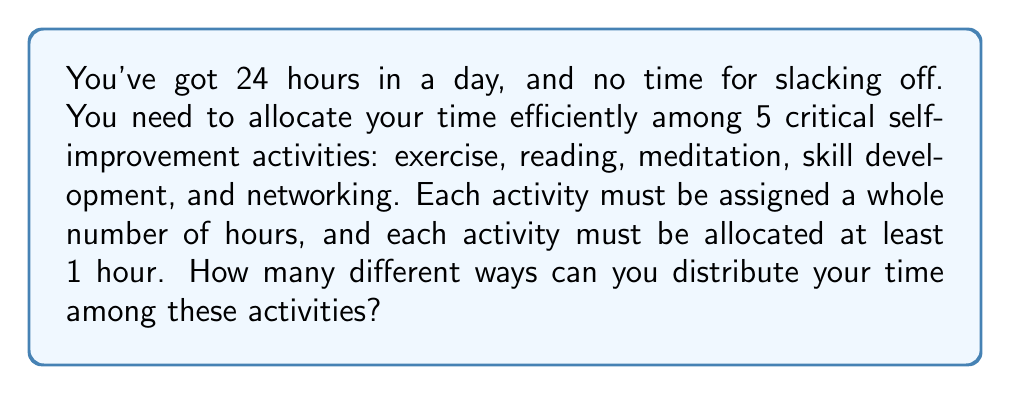Teach me how to tackle this problem. Let's approach this step-by-step:

1) This is a classic stars and bars problem in combinatorics. We need to distribute 24 indistinguishable objects (hours) into 5 distinguishable boxes (activities), with each box containing at least 1 object.

2) To ensure each activity gets at least 1 hour, we first allocate 1 hour to each activity:
   $24 - 5 = 19$ hours left to distribute

3) Now, we need to distribute 19 hours among 5 activities, with no restrictions on the number of hours per activity (including 0).

4) The formula for this scenario is:
   $$\binom{n+k-1}{k-1}$$
   where $n$ is the number of objects (remaining hours) and $k$ is the number of boxes (activities)

5) Plugging in our values:
   $$\binom{19+5-1}{5-1} = \binom{23}{4}$$

6) Calculate:
   $$\binom{23}{4} = \frac{23!}{4!(23-4)!} = \frac{23!}{4!19!} = 8855$$

Therefore, there are 8855 different ways to allocate your time efficiently among these 5 self-improvement activities. No excuses for not finding a schedule that works for you!
Answer: 8855 